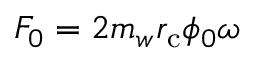<formula> <loc_0><loc_0><loc_500><loc_500>F _ { 0 } = 2 m _ { w } r _ { c } \phi _ { 0 } \omega</formula> 